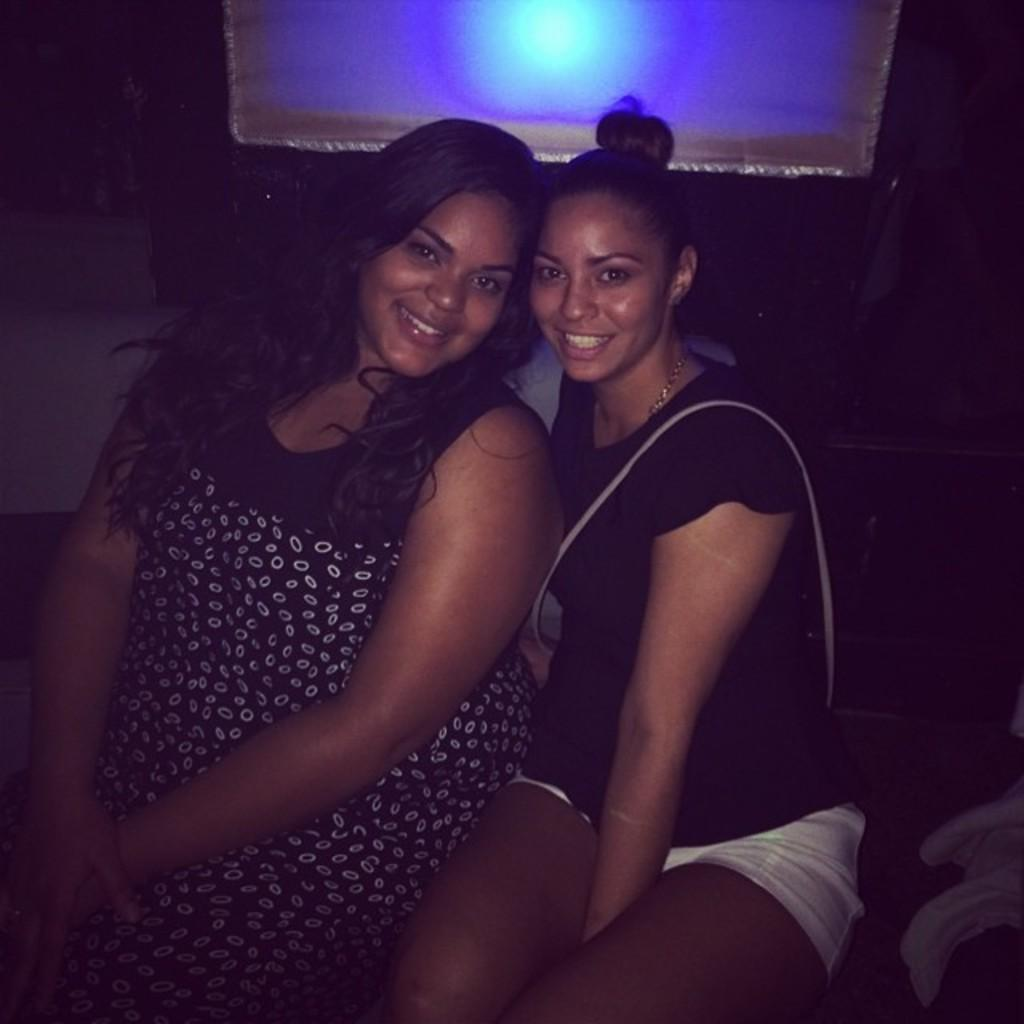How many people are present in the image? There are two people sitting in the image. What can be seen in the background of the image? There is some light visible in the background of the image. What is placed on the cloth in the image? There are objects on the cloth in the image. What type of nose can be seen on the sheet in the image? There is no nose or sheet present in the image. 